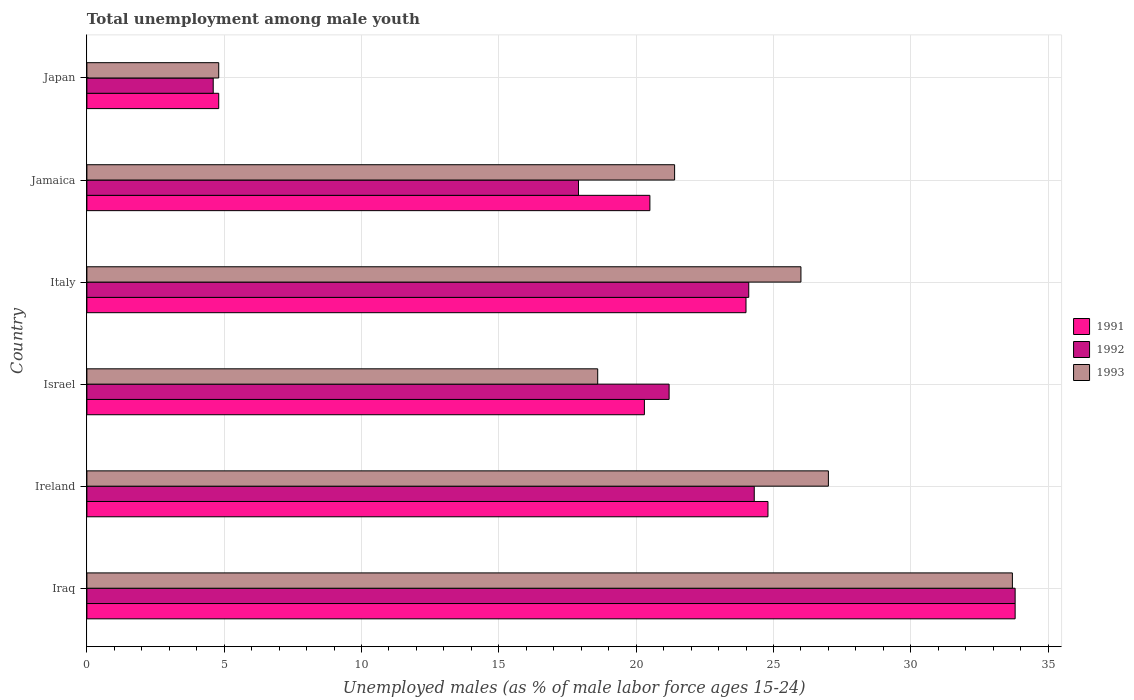How many different coloured bars are there?
Provide a succinct answer. 3. How many groups of bars are there?
Offer a very short reply. 6. Are the number of bars per tick equal to the number of legend labels?
Keep it short and to the point. Yes. Are the number of bars on each tick of the Y-axis equal?
Your answer should be very brief. Yes. How many bars are there on the 1st tick from the top?
Your answer should be very brief. 3. What is the label of the 4th group of bars from the top?
Keep it short and to the point. Israel. What is the percentage of unemployed males in in 1991 in Italy?
Give a very brief answer. 24. Across all countries, what is the maximum percentage of unemployed males in in 1991?
Your response must be concise. 33.8. Across all countries, what is the minimum percentage of unemployed males in in 1993?
Offer a very short reply. 4.8. In which country was the percentage of unemployed males in in 1992 maximum?
Offer a terse response. Iraq. What is the total percentage of unemployed males in in 1993 in the graph?
Provide a short and direct response. 131.5. What is the difference between the percentage of unemployed males in in 1993 in Iraq and that in Jamaica?
Your answer should be very brief. 12.3. What is the difference between the percentage of unemployed males in in 1992 in Iraq and the percentage of unemployed males in in 1991 in Japan?
Offer a very short reply. 29. What is the average percentage of unemployed males in in 1991 per country?
Offer a very short reply. 21.37. What is the difference between the percentage of unemployed males in in 1991 and percentage of unemployed males in in 1992 in Italy?
Offer a very short reply. -0.1. What is the ratio of the percentage of unemployed males in in 1991 in Iraq to that in Israel?
Make the answer very short. 1.67. Is the percentage of unemployed males in in 1991 in Ireland less than that in Jamaica?
Keep it short and to the point. No. Is the difference between the percentage of unemployed males in in 1991 in Ireland and Japan greater than the difference between the percentage of unemployed males in in 1992 in Ireland and Japan?
Offer a very short reply. Yes. What is the difference between the highest and the second highest percentage of unemployed males in in 1993?
Offer a very short reply. 6.7. What is the difference between the highest and the lowest percentage of unemployed males in in 1991?
Your answer should be compact. 29. In how many countries, is the percentage of unemployed males in in 1992 greater than the average percentage of unemployed males in in 1992 taken over all countries?
Keep it short and to the point. 4. What does the 3rd bar from the top in Ireland represents?
Provide a succinct answer. 1991. What does the 2nd bar from the bottom in Israel represents?
Provide a succinct answer. 1992. How many bars are there?
Offer a very short reply. 18. Are the values on the major ticks of X-axis written in scientific E-notation?
Your answer should be very brief. No. Does the graph contain any zero values?
Provide a short and direct response. No. Does the graph contain grids?
Your answer should be compact. Yes. How many legend labels are there?
Make the answer very short. 3. What is the title of the graph?
Provide a short and direct response. Total unemployment among male youth. What is the label or title of the X-axis?
Make the answer very short. Unemployed males (as % of male labor force ages 15-24). What is the label or title of the Y-axis?
Offer a terse response. Country. What is the Unemployed males (as % of male labor force ages 15-24) in 1991 in Iraq?
Your answer should be compact. 33.8. What is the Unemployed males (as % of male labor force ages 15-24) in 1992 in Iraq?
Give a very brief answer. 33.8. What is the Unemployed males (as % of male labor force ages 15-24) of 1993 in Iraq?
Provide a succinct answer. 33.7. What is the Unemployed males (as % of male labor force ages 15-24) of 1991 in Ireland?
Make the answer very short. 24.8. What is the Unemployed males (as % of male labor force ages 15-24) of 1992 in Ireland?
Provide a short and direct response. 24.3. What is the Unemployed males (as % of male labor force ages 15-24) in 1993 in Ireland?
Your response must be concise. 27. What is the Unemployed males (as % of male labor force ages 15-24) in 1991 in Israel?
Ensure brevity in your answer.  20.3. What is the Unemployed males (as % of male labor force ages 15-24) of 1992 in Israel?
Ensure brevity in your answer.  21.2. What is the Unemployed males (as % of male labor force ages 15-24) in 1993 in Israel?
Make the answer very short. 18.6. What is the Unemployed males (as % of male labor force ages 15-24) in 1992 in Italy?
Provide a succinct answer. 24.1. What is the Unemployed males (as % of male labor force ages 15-24) in 1993 in Italy?
Offer a terse response. 26. What is the Unemployed males (as % of male labor force ages 15-24) in 1992 in Jamaica?
Keep it short and to the point. 17.9. What is the Unemployed males (as % of male labor force ages 15-24) in 1993 in Jamaica?
Your answer should be compact. 21.4. What is the Unemployed males (as % of male labor force ages 15-24) of 1991 in Japan?
Keep it short and to the point. 4.8. What is the Unemployed males (as % of male labor force ages 15-24) in 1992 in Japan?
Your response must be concise. 4.6. What is the Unemployed males (as % of male labor force ages 15-24) in 1993 in Japan?
Give a very brief answer. 4.8. Across all countries, what is the maximum Unemployed males (as % of male labor force ages 15-24) of 1991?
Give a very brief answer. 33.8. Across all countries, what is the maximum Unemployed males (as % of male labor force ages 15-24) of 1992?
Ensure brevity in your answer.  33.8. Across all countries, what is the maximum Unemployed males (as % of male labor force ages 15-24) in 1993?
Your answer should be very brief. 33.7. Across all countries, what is the minimum Unemployed males (as % of male labor force ages 15-24) of 1991?
Provide a succinct answer. 4.8. Across all countries, what is the minimum Unemployed males (as % of male labor force ages 15-24) in 1992?
Keep it short and to the point. 4.6. Across all countries, what is the minimum Unemployed males (as % of male labor force ages 15-24) in 1993?
Your response must be concise. 4.8. What is the total Unemployed males (as % of male labor force ages 15-24) in 1991 in the graph?
Give a very brief answer. 128.2. What is the total Unemployed males (as % of male labor force ages 15-24) of 1992 in the graph?
Make the answer very short. 125.9. What is the total Unemployed males (as % of male labor force ages 15-24) of 1993 in the graph?
Your response must be concise. 131.5. What is the difference between the Unemployed males (as % of male labor force ages 15-24) in 1992 in Iraq and that in Ireland?
Offer a very short reply. 9.5. What is the difference between the Unemployed males (as % of male labor force ages 15-24) in 1993 in Iraq and that in Israel?
Keep it short and to the point. 15.1. What is the difference between the Unemployed males (as % of male labor force ages 15-24) of 1991 in Iraq and that in Italy?
Provide a short and direct response. 9.8. What is the difference between the Unemployed males (as % of male labor force ages 15-24) of 1993 in Iraq and that in Jamaica?
Offer a terse response. 12.3. What is the difference between the Unemployed males (as % of male labor force ages 15-24) in 1992 in Iraq and that in Japan?
Your answer should be very brief. 29.2. What is the difference between the Unemployed males (as % of male labor force ages 15-24) of 1993 in Iraq and that in Japan?
Your answer should be very brief. 28.9. What is the difference between the Unemployed males (as % of male labor force ages 15-24) of 1991 in Ireland and that in Italy?
Your answer should be very brief. 0.8. What is the difference between the Unemployed males (as % of male labor force ages 15-24) in 1992 in Ireland and that in Italy?
Make the answer very short. 0.2. What is the difference between the Unemployed males (as % of male labor force ages 15-24) of 1992 in Ireland and that in Jamaica?
Provide a short and direct response. 6.4. What is the difference between the Unemployed males (as % of male labor force ages 15-24) in 1991 in Ireland and that in Japan?
Make the answer very short. 20. What is the difference between the Unemployed males (as % of male labor force ages 15-24) of 1992 in Ireland and that in Japan?
Offer a very short reply. 19.7. What is the difference between the Unemployed males (as % of male labor force ages 15-24) of 1993 in Ireland and that in Japan?
Keep it short and to the point. 22.2. What is the difference between the Unemployed males (as % of male labor force ages 15-24) of 1992 in Israel and that in Italy?
Provide a succinct answer. -2.9. What is the difference between the Unemployed males (as % of male labor force ages 15-24) in 1991 in Israel and that in Jamaica?
Provide a succinct answer. -0.2. What is the difference between the Unemployed males (as % of male labor force ages 15-24) in 1993 in Israel and that in Jamaica?
Offer a terse response. -2.8. What is the difference between the Unemployed males (as % of male labor force ages 15-24) of 1992 in Israel and that in Japan?
Your answer should be compact. 16.6. What is the difference between the Unemployed males (as % of male labor force ages 15-24) in 1993 in Israel and that in Japan?
Offer a terse response. 13.8. What is the difference between the Unemployed males (as % of male labor force ages 15-24) of 1992 in Italy and that in Jamaica?
Offer a very short reply. 6.2. What is the difference between the Unemployed males (as % of male labor force ages 15-24) in 1993 in Italy and that in Jamaica?
Provide a short and direct response. 4.6. What is the difference between the Unemployed males (as % of male labor force ages 15-24) in 1991 in Italy and that in Japan?
Ensure brevity in your answer.  19.2. What is the difference between the Unemployed males (as % of male labor force ages 15-24) in 1992 in Italy and that in Japan?
Offer a terse response. 19.5. What is the difference between the Unemployed males (as % of male labor force ages 15-24) in 1993 in Italy and that in Japan?
Your response must be concise. 21.2. What is the difference between the Unemployed males (as % of male labor force ages 15-24) in 1992 in Jamaica and that in Japan?
Ensure brevity in your answer.  13.3. What is the difference between the Unemployed males (as % of male labor force ages 15-24) of 1991 in Iraq and the Unemployed males (as % of male labor force ages 15-24) of 1993 in Ireland?
Make the answer very short. 6.8. What is the difference between the Unemployed males (as % of male labor force ages 15-24) in 1991 in Iraq and the Unemployed males (as % of male labor force ages 15-24) in 1992 in Israel?
Give a very brief answer. 12.6. What is the difference between the Unemployed males (as % of male labor force ages 15-24) in 1991 in Iraq and the Unemployed males (as % of male labor force ages 15-24) in 1992 in Italy?
Offer a very short reply. 9.7. What is the difference between the Unemployed males (as % of male labor force ages 15-24) in 1991 in Iraq and the Unemployed males (as % of male labor force ages 15-24) in 1992 in Japan?
Keep it short and to the point. 29.2. What is the difference between the Unemployed males (as % of male labor force ages 15-24) of 1992 in Iraq and the Unemployed males (as % of male labor force ages 15-24) of 1993 in Japan?
Your answer should be very brief. 29. What is the difference between the Unemployed males (as % of male labor force ages 15-24) of 1991 in Ireland and the Unemployed males (as % of male labor force ages 15-24) of 1992 in Israel?
Your response must be concise. 3.6. What is the difference between the Unemployed males (as % of male labor force ages 15-24) in 1991 in Ireland and the Unemployed males (as % of male labor force ages 15-24) in 1993 in Israel?
Your response must be concise. 6.2. What is the difference between the Unemployed males (as % of male labor force ages 15-24) in 1991 in Ireland and the Unemployed males (as % of male labor force ages 15-24) in 1992 in Jamaica?
Give a very brief answer. 6.9. What is the difference between the Unemployed males (as % of male labor force ages 15-24) in 1991 in Ireland and the Unemployed males (as % of male labor force ages 15-24) in 1993 in Jamaica?
Your response must be concise. 3.4. What is the difference between the Unemployed males (as % of male labor force ages 15-24) in 1991 in Ireland and the Unemployed males (as % of male labor force ages 15-24) in 1992 in Japan?
Give a very brief answer. 20.2. What is the difference between the Unemployed males (as % of male labor force ages 15-24) in 1991 in Israel and the Unemployed males (as % of male labor force ages 15-24) in 1992 in Jamaica?
Your response must be concise. 2.4. What is the difference between the Unemployed males (as % of male labor force ages 15-24) in 1991 in Israel and the Unemployed males (as % of male labor force ages 15-24) in 1993 in Jamaica?
Provide a short and direct response. -1.1. What is the difference between the Unemployed males (as % of male labor force ages 15-24) of 1992 in Israel and the Unemployed males (as % of male labor force ages 15-24) of 1993 in Jamaica?
Your answer should be very brief. -0.2. What is the difference between the Unemployed males (as % of male labor force ages 15-24) in 1991 in Israel and the Unemployed males (as % of male labor force ages 15-24) in 1992 in Japan?
Provide a short and direct response. 15.7. What is the difference between the Unemployed males (as % of male labor force ages 15-24) of 1991 in Israel and the Unemployed males (as % of male labor force ages 15-24) of 1993 in Japan?
Make the answer very short. 15.5. What is the difference between the Unemployed males (as % of male labor force ages 15-24) in 1991 in Italy and the Unemployed males (as % of male labor force ages 15-24) in 1992 in Jamaica?
Make the answer very short. 6.1. What is the difference between the Unemployed males (as % of male labor force ages 15-24) of 1991 in Italy and the Unemployed males (as % of male labor force ages 15-24) of 1993 in Jamaica?
Make the answer very short. 2.6. What is the difference between the Unemployed males (as % of male labor force ages 15-24) of 1992 in Italy and the Unemployed males (as % of male labor force ages 15-24) of 1993 in Jamaica?
Keep it short and to the point. 2.7. What is the difference between the Unemployed males (as % of male labor force ages 15-24) of 1992 in Italy and the Unemployed males (as % of male labor force ages 15-24) of 1993 in Japan?
Give a very brief answer. 19.3. What is the difference between the Unemployed males (as % of male labor force ages 15-24) of 1991 in Jamaica and the Unemployed males (as % of male labor force ages 15-24) of 1992 in Japan?
Provide a short and direct response. 15.9. What is the difference between the Unemployed males (as % of male labor force ages 15-24) in 1991 in Jamaica and the Unemployed males (as % of male labor force ages 15-24) in 1993 in Japan?
Your response must be concise. 15.7. What is the average Unemployed males (as % of male labor force ages 15-24) in 1991 per country?
Give a very brief answer. 21.37. What is the average Unemployed males (as % of male labor force ages 15-24) in 1992 per country?
Offer a very short reply. 20.98. What is the average Unemployed males (as % of male labor force ages 15-24) of 1993 per country?
Your answer should be very brief. 21.92. What is the difference between the Unemployed males (as % of male labor force ages 15-24) of 1991 and Unemployed males (as % of male labor force ages 15-24) of 1993 in Iraq?
Make the answer very short. 0.1. What is the difference between the Unemployed males (as % of male labor force ages 15-24) in 1992 and Unemployed males (as % of male labor force ages 15-24) in 1993 in Iraq?
Provide a short and direct response. 0.1. What is the difference between the Unemployed males (as % of male labor force ages 15-24) in 1991 and Unemployed males (as % of male labor force ages 15-24) in 1992 in Ireland?
Keep it short and to the point. 0.5. What is the difference between the Unemployed males (as % of male labor force ages 15-24) of 1991 and Unemployed males (as % of male labor force ages 15-24) of 1993 in Ireland?
Offer a very short reply. -2.2. What is the difference between the Unemployed males (as % of male labor force ages 15-24) in 1992 and Unemployed males (as % of male labor force ages 15-24) in 1993 in Israel?
Provide a short and direct response. 2.6. What is the difference between the Unemployed males (as % of male labor force ages 15-24) in 1991 and Unemployed males (as % of male labor force ages 15-24) in 1993 in Italy?
Provide a succinct answer. -2. What is the difference between the Unemployed males (as % of male labor force ages 15-24) of 1992 and Unemployed males (as % of male labor force ages 15-24) of 1993 in Italy?
Provide a succinct answer. -1.9. What is the difference between the Unemployed males (as % of male labor force ages 15-24) in 1991 and Unemployed males (as % of male labor force ages 15-24) in 1993 in Jamaica?
Make the answer very short. -0.9. What is the difference between the Unemployed males (as % of male labor force ages 15-24) in 1992 and Unemployed males (as % of male labor force ages 15-24) in 1993 in Japan?
Ensure brevity in your answer.  -0.2. What is the ratio of the Unemployed males (as % of male labor force ages 15-24) of 1991 in Iraq to that in Ireland?
Make the answer very short. 1.36. What is the ratio of the Unemployed males (as % of male labor force ages 15-24) of 1992 in Iraq to that in Ireland?
Offer a terse response. 1.39. What is the ratio of the Unemployed males (as % of male labor force ages 15-24) in 1993 in Iraq to that in Ireland?
Give a very brief answer. 1.25. What is the ratio of the Unemployed males (as % of male labor force ages 15-24) of 1991 in Iraq to that in Israel?
Keep it short and to the point. 1.67. What is the ratio of the Unemployed males (as % of male labor force ages 15-24) of 1992 in Iraq to that in Israel?
Your answer should be compact. 1.59. What is the ratio of the Unemployed males (as % of male labor force ages 15-24) in 1993 in Iraq to that in Israel?
Provide a succinct answer. 1.81. What is the ratio of the Unemployed males (as % of male labor force ages 15-24) in 1991 in Iraq to that in Italy?
Give a very brief answer. 1.41. What is the ratio of the Unemployed males (as % of male labor force ages 15-24) in 1992 in Iraq to that in Italy?
Make the answer very short. 1.4. What is the ratio of the Unemployed males (as % of male labor force ages 15-24) in 1993 in Iraq to that in Italy?
Ensure brevity in your answer.  1.3. What is the ratio of the Unemployed males (as % of male labor force ages 15-24) of 1991 in Iraq to that in Jamaica?
Your response must be concise. 1.65. What is the ratio of the Unemployed males (as % of male labor force ages 15-24) in 1992 in Iraq to that in Jamaica?
Provide a succinct answer. 1.89. What is the ratio of the Unemployed males (as % of male labor force ages 15-24) in 1993 in Iraq to that in Jamaica?
Provide a succinct answer. 1.57. What is the ratio of the Unemployed males (as % of male labor force ages 15-24) in 1991 in Iraq to that in Japan?
Your answer should be very brief. 7.04. What is the ratio of the Unemployed males (as % of male labor force ages 15-24) in 1992 in Iraq to that in Japan?
Provide a short and direct response. 7.35. What is the ratio of the Unemployed males (as % of male labor force ages 15-24) of 1993 in Iraq to that in Japan?
Your answer should be very brief. 7.02. What is the ratio of the Unemployed males (as % of male labor force ages 15-24) of 1991 in Ireland to that in Israel?
Provide a succinct answer. 1.22. What is the ratio of the Unemployed males (as % of male labor force ages 15-24) of 1992 in Ireland to that in Israel?
Your answer should be compact. 1.15. What is the ratio of the Unemployed males (as % of male labor force ages 15-24) of 1993 in Ireland to that in Israel?
Give a very brief answer. 1.45. What is the ratio of the Unemployed males (as % of male labor force ages 15-24) of 1992 in Ireland to that in Italy?
Provide a short and direct response. 1.01. What is the ratio of the Unemployed males (as % of male labor force ages 15-24) of 1993 in Ireland to that in Italy?
Provide a succinct answer. 1.04. What is the ratio of the Unemployed males (as % of male labor force ages 15-24) in 1991 in Ireland to that in Jamaica?
Your answer should be compact. 1.21. What is the ratio of the Unemployed males (as % of male labor force ages 15-24) in 1992 in Ireland to that in Jamaica?
Offer a very short reply. 1.36. What is the ratio of the Unemployed males (as % of male labor force ages 15-24) in 1993 in Ireland to that in Jamaica?
Offer a terse response. 1.26. What is the ratio of the Unemployed males (as % of male labor force ages 15-24) in 1991 in Ireland to that in Japan?
Provide a succinct answer. 5.17. What is the ratio of the Unemployed males (as % of male labor force ages 15-24) in 1992 in Ireland to that in Japan?
Provide a short and direct response. 5.28. What is the ratio of the Unemployed males (as % of male labor force ages 15-24) of 1993 in Ireland to that in Japan?
Offer a very short reply. 5.62. What is the ratio of the Unemployed males (as % of male labor force ages 15-24) in 1991 in Israel to that in Italy?
Give a very brief answer. 0.85. What is the ratio of the Unemployed males (as % of male labor force ages 15-24) of 1992 in Israel to that in Italy?
Ensure brevity in your answer.  0.88. What is the ratio of the Unemployed males (as % of male labor force ages 15-24) of 1993 in Israel to that in Italy?
Offer a terse response. 0.72. What is the ratio of the Unemployed males (as % of male labor force ages 15-24) in 1991 in Israel to that in Jamaica?
Offer a terse response. 0.99. What is the ratio of the Unemployed males (as % of male labor force ages 15-24) of 1992 in Israel to that in Jamaica?
Keep it short and to the point. 1.18. What is the ratio of the Unemployed males (as % of male labor force ages 15-24) of 1993 in Israel to that in Jamaica?
Your response must be concise. 0.87. What is the ratio of the Unemployed males (as % of male labor force ages 15-24) of 1991 in Israel to that in Japan?
Your answer should be very brief. 4.23. What is the ratio of the Unemployed males (as % of male labor force ages 15-24) in 1992 in Israel to that in Japan?
Make the answer very short. 4.61. What is the ratio of the Unemployed males (as % of male labor force ages 15-24) of 1993 in Israel to that in Japan?
Your response must be concise. 3.88. What is the ratio of the Unemployed males (as % of male labor force ages 15-24) of 1991 in Italy to that in Jamaica?
Your answer should be compact. 1.17. What is the ratio of the Unemployed males (as % of male labor force ages 15-24) in 1992 in Italy to that in Jamaica?
Your answer should be very brief. 1.35. What is the ratio of the Unemployed males (as % of male labor force ages 15-24) of 1993 in Italy to that in Jamaica?
Provide a short and direct response. 1.22. What is the ratio of the Unemployed males (as % of male labor force ages 15-24) in 1992 in Italy to that in Japan?
Provide a succinct answer. 5.24. What is the ratio of the Unemployed males (as % of male labor force ages 15-24) in 1993 in Italy to that in Japan?
Give a very brief answer. 5.42. What is the ratio of the Unemployed males (as % of male labor force ages 15-24) in 1991 in Jamaica to that in Japan?
Your response must be concise. 4.27. What is the ratio of the Unemployed males (as % of male labor force ages 15-24) of 1992 in Jamaica to that in Japan?
Your answer should be very brief. 3.89. What is the ratio of the Unemployed males (as % of male labor force ages 15-24) of 1993 in Jamaica to that in Japan?
Ensure brevity in your answer.  4.46. What is the difference between the highest and the second highest Unemployed males (as % of male labor force ages 15-24) in 1993?
Your answer should be compact. 6.7. What is the difference between the highest and the lowest Unemployed males (as % of male labor force ages 15-24) of 1991?
Keep it short and to the point. 29. What is the difference between the highest and the lowest Unemployed males (as % of male labor force ages 15-24) in 1992?
Your response must be concise. 29.2. What is the difference between the highest and the lowest Unemployed males (as % of male labor force ages 15-24) in 1993?
Your response must be concise. 28.9. 